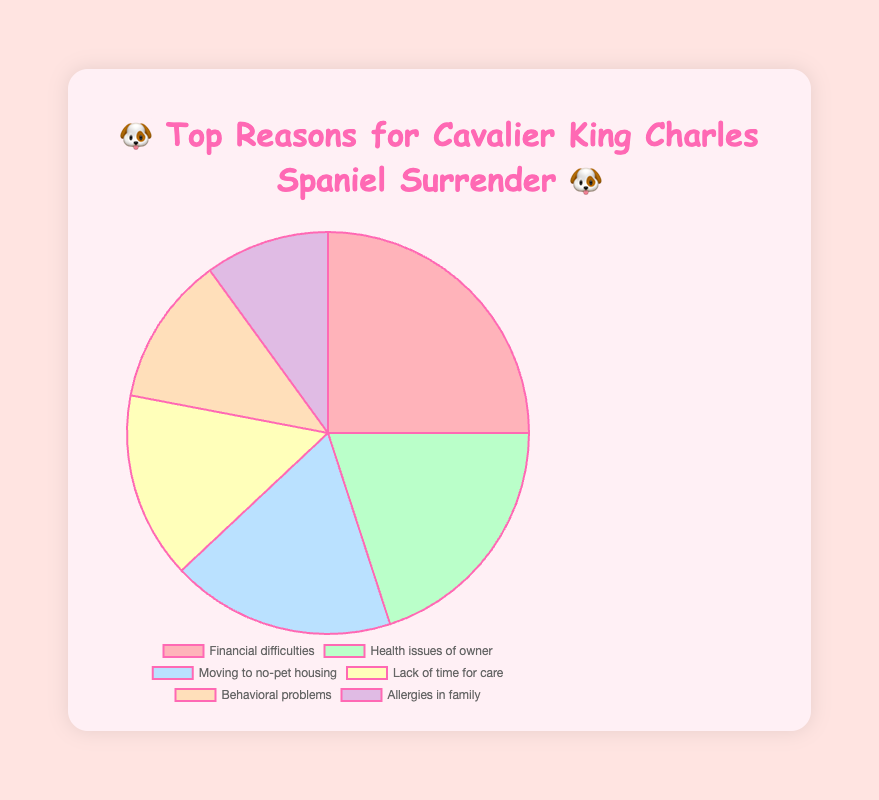what's the title of the chart? The chart title is prominently displayed at the top of the figure, above the chart itself. It helps to identify the main topic or subject of the chart.
Answer: 🐶 Top Reasons for Cavalier King Charles Spaniel Surrender 🐶 how many different reasons are shown in the chart? Count the number of distinct slices or labels shown within the legend or directly on the pie chart. Each slice represents a different reason for surrender.
Answer: 6 which reason has the highest percentage? Look at the largest slice of the pie chart and identify its label and associated percentage.
Answer: Financial difficulties which two reasons combined account for the same percentage as "moving to no-pet housing"? Identify the reasons and their respective percentages and then sum combinations to find those adding up to 18%.
Answer: Lack of time for care (15%) + Allergies in family (10%) - 3% extra what is the difference in percentage between "financial difficulties" and "health issues of owner"? Subtract the smaller percentage from the larger one to find the difference between the two highlighted categories.
Answer: 5% which reason is represented by the emoji 🤧? Look at the slice of the pie chart or the legend where the label includes the emoji 🤧 and its corresponding reason.
Answer: Allergies in family how much larger is the percentage of "financial difficulties" compared to "behavioral problems"? Subtract the percentage of "behavioral problems" from "financial difficulties" to identify the difference.
Answer: 13% what is the combined percentage of "health issues of owner" and "moving to no-pet housing"? Sum the percentages of both categories to get the total percentage.
Answer: 38% what two reasons together have a larger percentage than "financial difficulties"? Identify pairs of percentages from the chart that, when summed, exceed the largest single slice's percentage.
Answer: Health issues of owner (20%) and Moving to no-pet housing (18%) - 38% which reason represented by an emoji has the smallest percentage, and what is the emoji? Identify the slice or legend entry with the smallest percentage and check its associated emoji.
Answer: Allergies in family, 🤧 